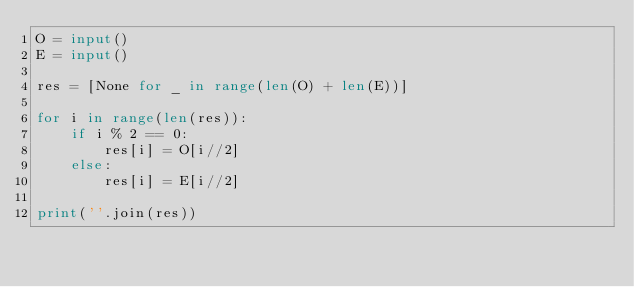Convert code to text. <code><loc_0><loc_0><loc_500><loc_500><_Python_>O = input()
E = input()

res = [None for _ in range(len(O) + len(E))]

for i in range(len(res)):
    if i % 2 == 0:
        res[i] = O[i//2]
    else:
        res[i] = E[i//2]

print(''.join(res))</code> 